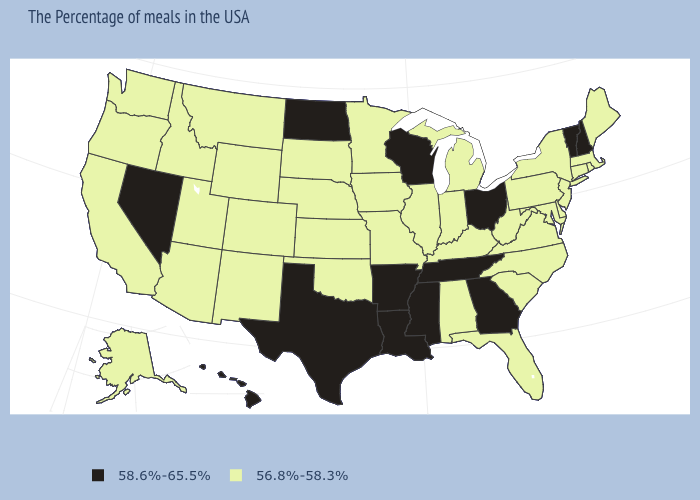What is the highest value in the West ?
Be succinct. 58.6%-65.5%. Does Connecticut have a lower value than Georgia?
Quick response, please. Yes. Name the states that have a value in the range 58.6%-65.5%?
Quick response, please. New Hampshire, Vermont, Ohio, Georgia, Tennessee, Wisconsin, Mississippi, Louisiana, Arkansas, Texas, North Dakota, Nevada, Hawaii. Name the states that have a value in the range 56.8%-58.3%?
Answer briefly. Maine, Massachusetts, Rhode Island, Connecticut, New York, New Jersey, Delaware, Maryland, Pennsylvania, Virginia, North Carolina, South Carolina, West Virginia, Florida, Michigan, Kentucky, Indiana, Alabama, Illinois, Missouri, Minnesota, Iowa, Kansas, Nebraska, Oklahoma, South Dakota, Wyoming, Colorado, New Mexico, Utah, Montana, Arizona, Idaho, California, Washington, Oregon, Alaska. Which states have the lowest value in the South?
Give a very brief answer. Delaware, Maryland, Virginia, North Carolina, South Carolina, West Virginia, Florida, Kentucky, Alabama, Oklahoma. What is the value of Minnesota?
Answer briefly. 56.8%-58.3%. What is the value of New Jersey?
Be succinct. 56.8%-58.3%. Which states have the lowest value in the West?
Concise answer only. Wyoming, Colorado, New Mexico, Utah, Montana, Arizona, Idaho, California, Washington, Oregon, Alaska. Does Ohio have the highest value in the USA?
Write a very short answer. Yes. What is the value of New Hampshire?
Be succinct. 58.6%-65.5%. What is the value of New Mexico?
Give a very brief answer. 56.8%-58.3%. What is the value of Iowa?
Quick response, please. 56.8%-58.3%. Which states have the highest value in the USA?
Write a very short answer. New Hampshire, Vermont, Ohio, Georgia, Tennessee, Wisconsin, Mississippi, Louisiana, Arkansas, Texas, North Dakota, Nevada, Hawaii. How many symbols are there in the legend?
Give a very brief answer. 2. Name the states that have a value in the range 58.6%-65.5%?
Short answer required. New Hampshire, Vermont, Ohio, Georgia, Tennessee, Wisconsin, Mississippi, Louisiana, Arkansas, Texas, North Dakota, Nevada, Hawaii. 